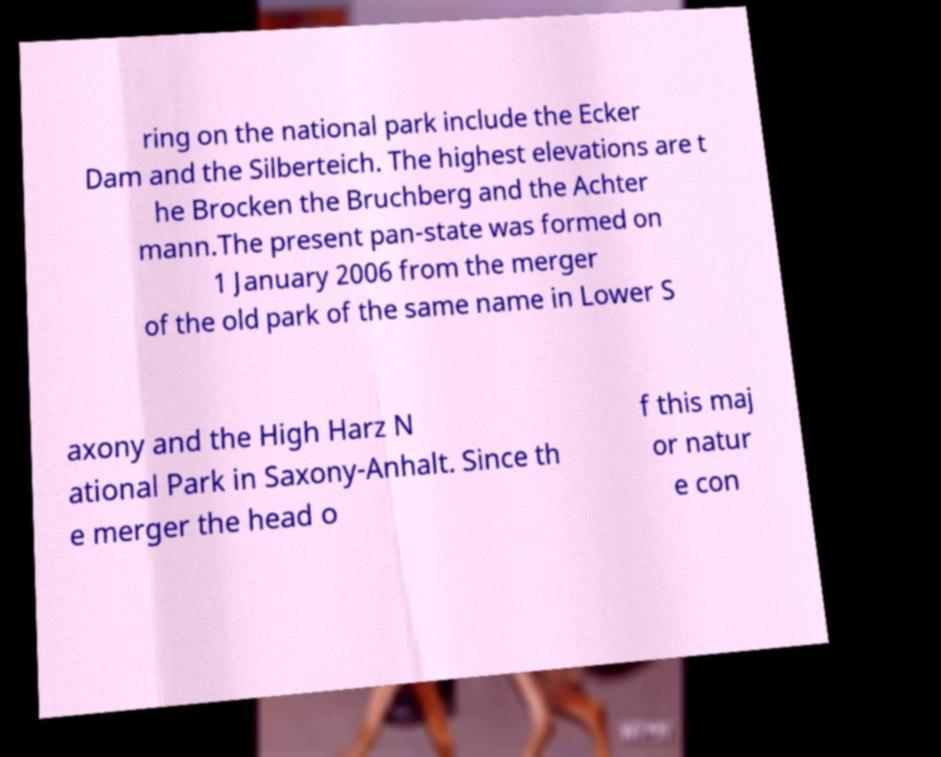Could you extract and type out the text from this image? ring on the national park include the Ecker Dam and the Silberteich. The highest elevations are t he Brocken the Bruchberg and the Achter mann.The present pan-state was formed on 1 January 2006 from the merger of the old park of the same name in Lower S axony and the High Harz N ational Park in Saxony-Anhalt. Since th e merger the head o f this maj or natur e con 